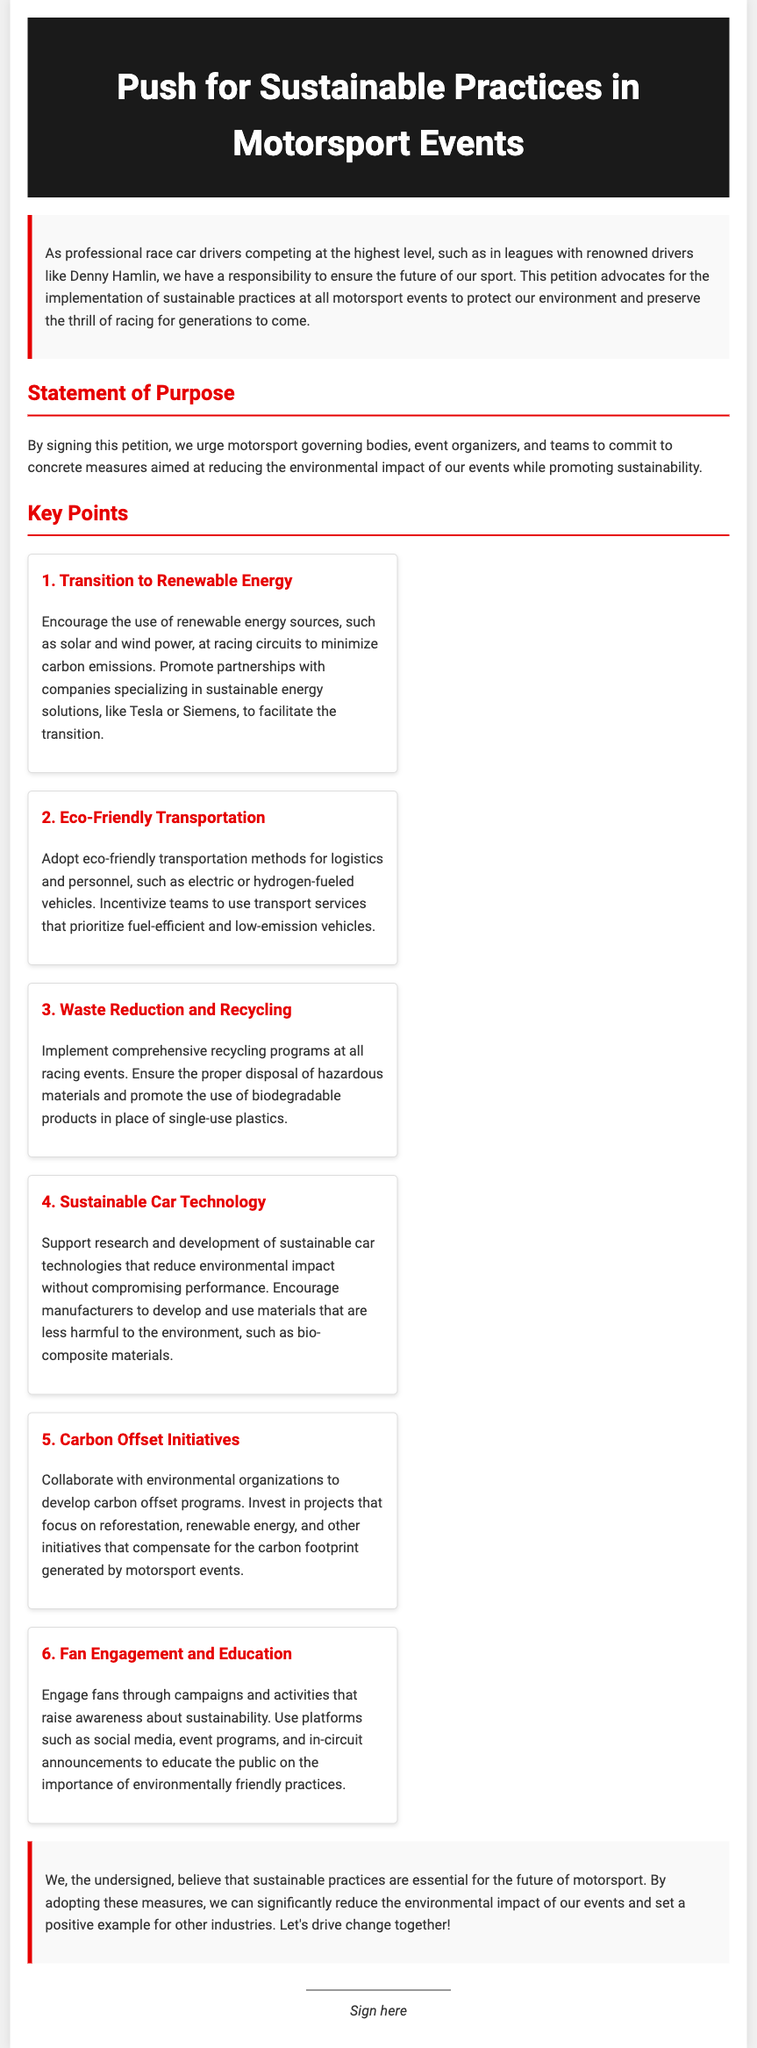What is the purpose of the petition? The purpose is to urge motorsport governing bodies, event organizers, and teams to commit to measures aimed at reducing environmental impact.
Answer: To reduce environmental impact How many key points are outlined in the petition? The document lists a total of six key points.
Answer: Six What is one recommended source of renewable energy mentioned? The document mentions solar and wind power as recommended renewable energy sources.
Answer: Solar and wind power What does the petition suggest for waste management? The petition suggests implementing comprehensive recycling programs at all racing events.
Answer: Recycling programs Who are we encouraged to partner with for carbon offset initiatives? Environmental organizations are mentioned as partners for developing carbon offset programs.
Answer: Environmental organizations What material is suggested for sustainable car technology? The document suggests using bio-composite materials for sustainable car technologies.
Answer: Bio-composite materials What is one method of fan engagement mentioned in the petition? The petition mentions using social media to raise awareness about sustainability among fans.
Answer: Social media What is emphasized as essential for the future of motorsport? The document emphasizes sustainable practices as essential for the future of motorsport.
Answer: Sustainable practices 